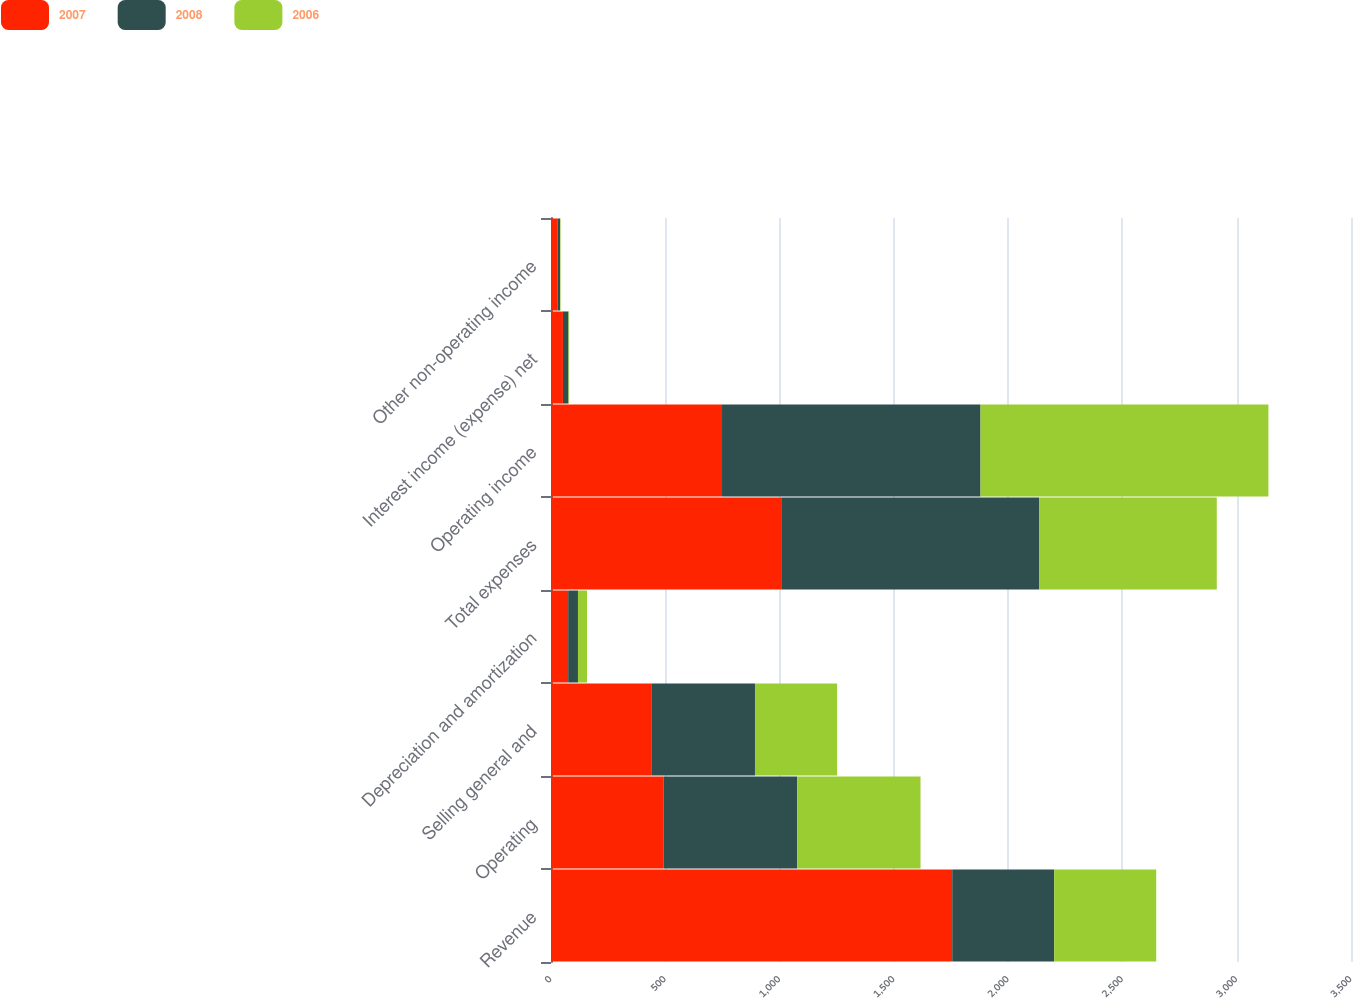Convert chart to OTSL. <chart><loc_0><loc_0><loc_500><loc_500><stacked_bar_chart><ecel><fcel>Revenue<fcel>Operating<fcel>Selling general and<fcel>Depreciation and amortization<fcel>Total expenses<fcel>Operating income<fcel>Interest income (expense) net<fcel>Other non-operating income<nl><fcel>2007<fcel>1755.4<fcel>493.3<fcel>441.3<fcel>75.1<fcel>1007.2<fcel>748.2<fcel>52.2<fcel>29.8<nl><fcel>2008<fcel>446.2<fcel>584<fcel>451.1<fcel>42.9<fcel>1128<fcel>1131<fcel>24.3<fcel>10<nl><fcel>2006<fcel>446.2<fcel>539.4<fcel>359.3<fcel>39.5<fcel>777.6<fcel>1259.5<fcel>3<fcel>2<nl></chart> 